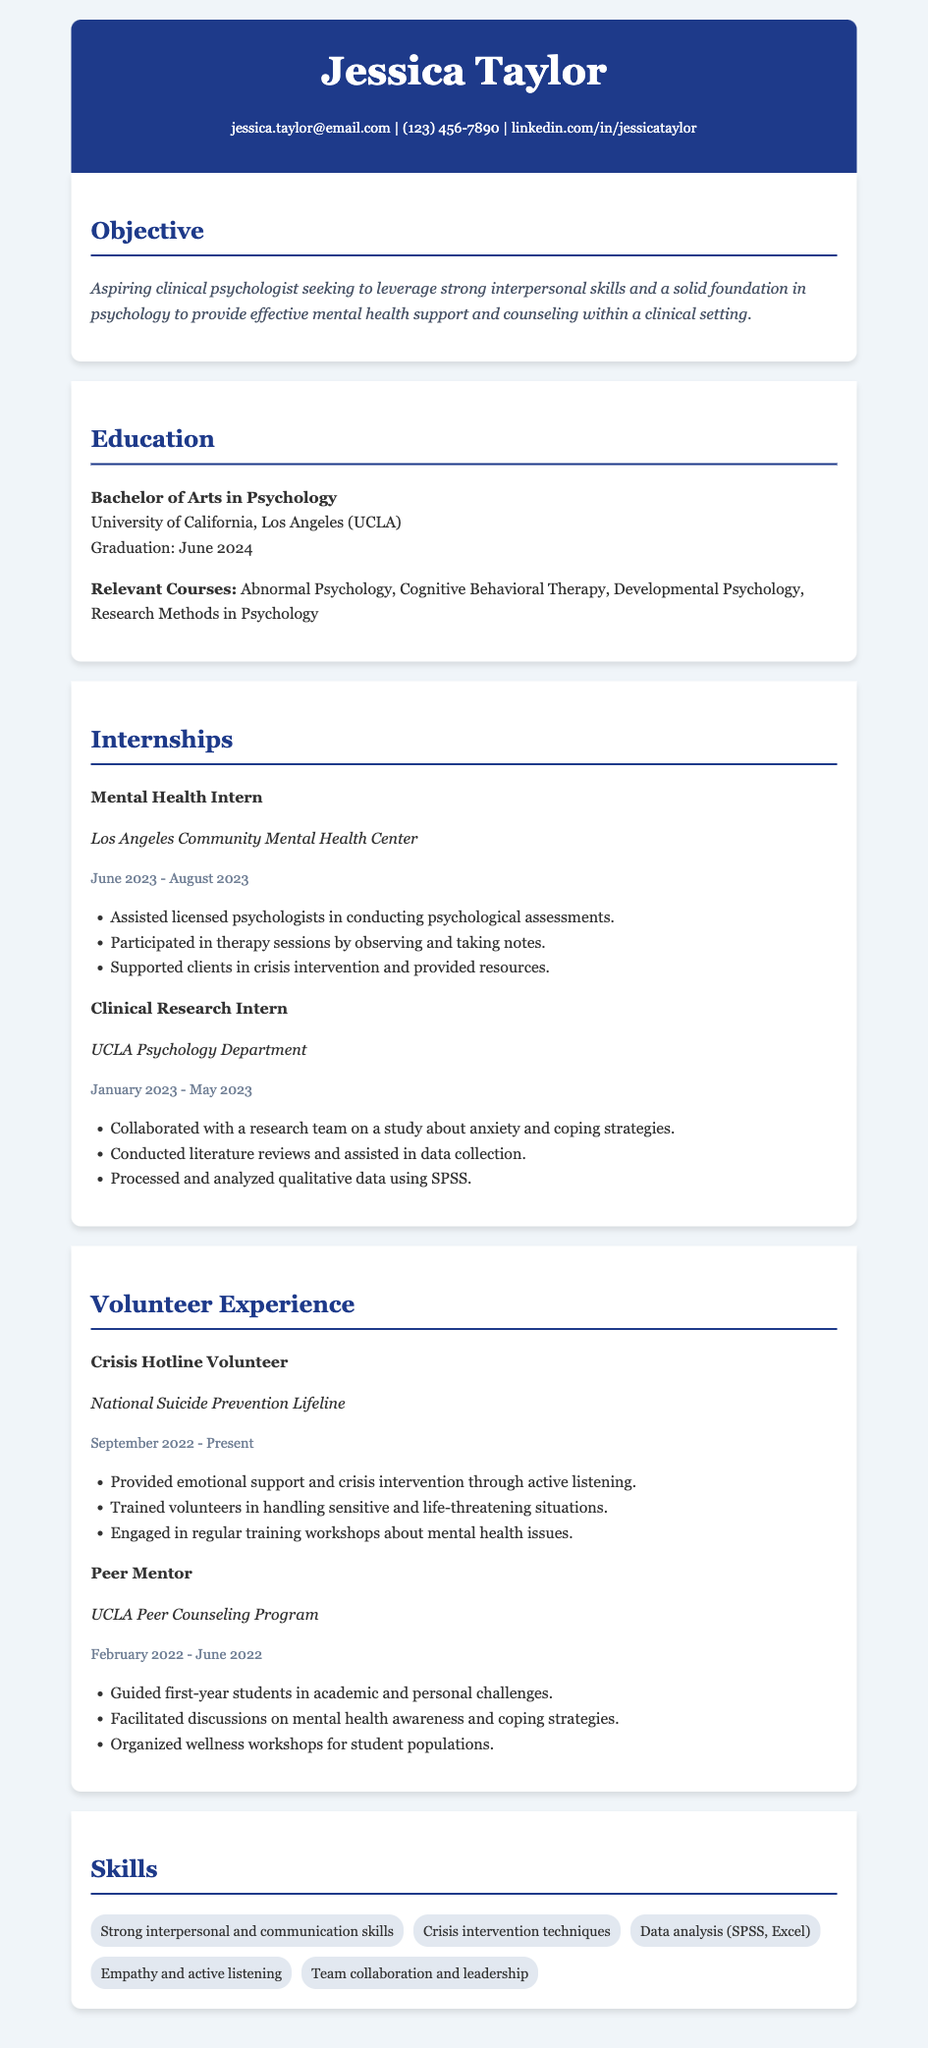What is the candidate's name? The candidate's name is prominently displayed in the header of the document.
Answer: Jessica Taylor When is the expected graduation date? The expected graduation date is mentioned in the education section as the time when the candidate will complete their degree.
Answer: June 2024 What position did Jessica hold at the Los Angeles Community Mental Health Center? The specific role is detailed in the internships section, indicating the candidate's position and responsibilities during their internship.
Answer: Mental Health Intern Which organization does Jessica volunteer for? The volunteer experience section lists the organizations where the candidate has contributed their time and skills.
Answer: National Suicide Prevention Lifeline What skills are highlighted in the resume? The skills section provides a list of relevant abilities that support the candidate's qualifications for a clinical psychology career.
Answer: Strong interpersonal and communication skills How many internships are listed on the resume? The number of internships indicates the practical experiences Jessica has had in the field, which are outlined in their resume.
Answer: Two What course related to therapy is included in the education section? The relevant courses listed in the education section showcase the candidate's academic background and training.
Answer: Cognitive Behavioral Therapy What role did Jessica have in the UCLA Peer Counseling Program? This role provided insights into Jessica's responsibilities and contributions in a peer-support environment.
Answer: Peer Mentor 